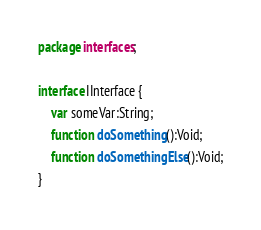<code> <loc_0><loc_0><loc_500><loc_500><_Haxe_>package interfaces;

interface IInterface {
	var someVar:String;
	function doSomething():Void;
	function doSomethingElse():Void;
}
</code> 